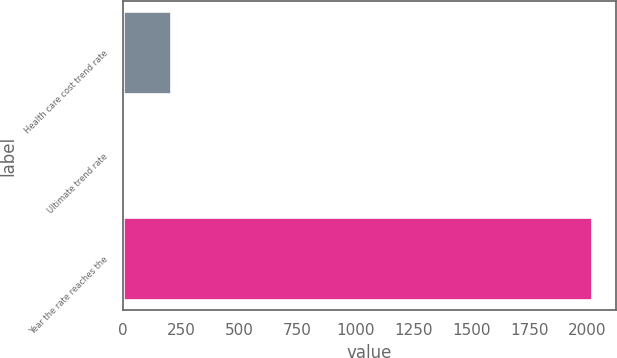Convert chart. <chart><loc_0><loc_0><loc_500><loc_500><bar_chart><fcel>Health care cost trend rate<fcel>Ultimate trend rate<fcel>Year the rate reaches the<nl><fcel>206.5<fcel>5<fcel>2020<nl></chart> 